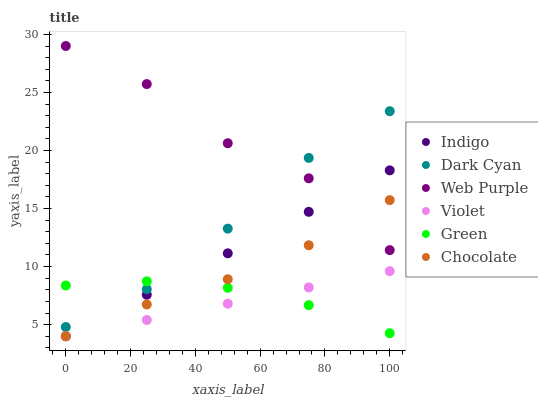Does Violet have the minimum area under the curve?
Answer yes or no. Yes. Does Web Purple have the maximum area under the curve?
Answer yes or no. Yes. Does Chocolate have the minimum area under the curve?
Answer yes or no. No. Does Chocolate have the maximum area under the curve?
Answer yes or no. No. Is Indigo the smoothest?
Answer yes or no. Yes. Is Web Purple the roughest?
Answer yes or no. Yes. Is Chocolate the smoothest?
Answer yes or no. No. Is Chocolate the roughest?
Answer yes or no. No. Does Indigo have the lowest value?
Answer yes or no. Yes. Does Web Purple have the lowest value?
Answer yes or no. No. Does Web Purple have the highest value?
Answer yes or no. Yes. Does Chocolate have the highest value?
Answer yes or no. No. Is Chocolate less than Dark Cyan?
Answer yes or no. Yes. Is Dark Cyan greater than Chocolate?
Answer yes or no. Yes. Does Web Purple intersect Chocolate?
Answer yes or no. Yes. Is Web Purple less than Chocolate?
Answer yes or no. No. Is Web Purple greater than Chocolate?
Answer yes or no. No. Does Chocolate intersect Dark Cyan?
Answer yes or no. No. 